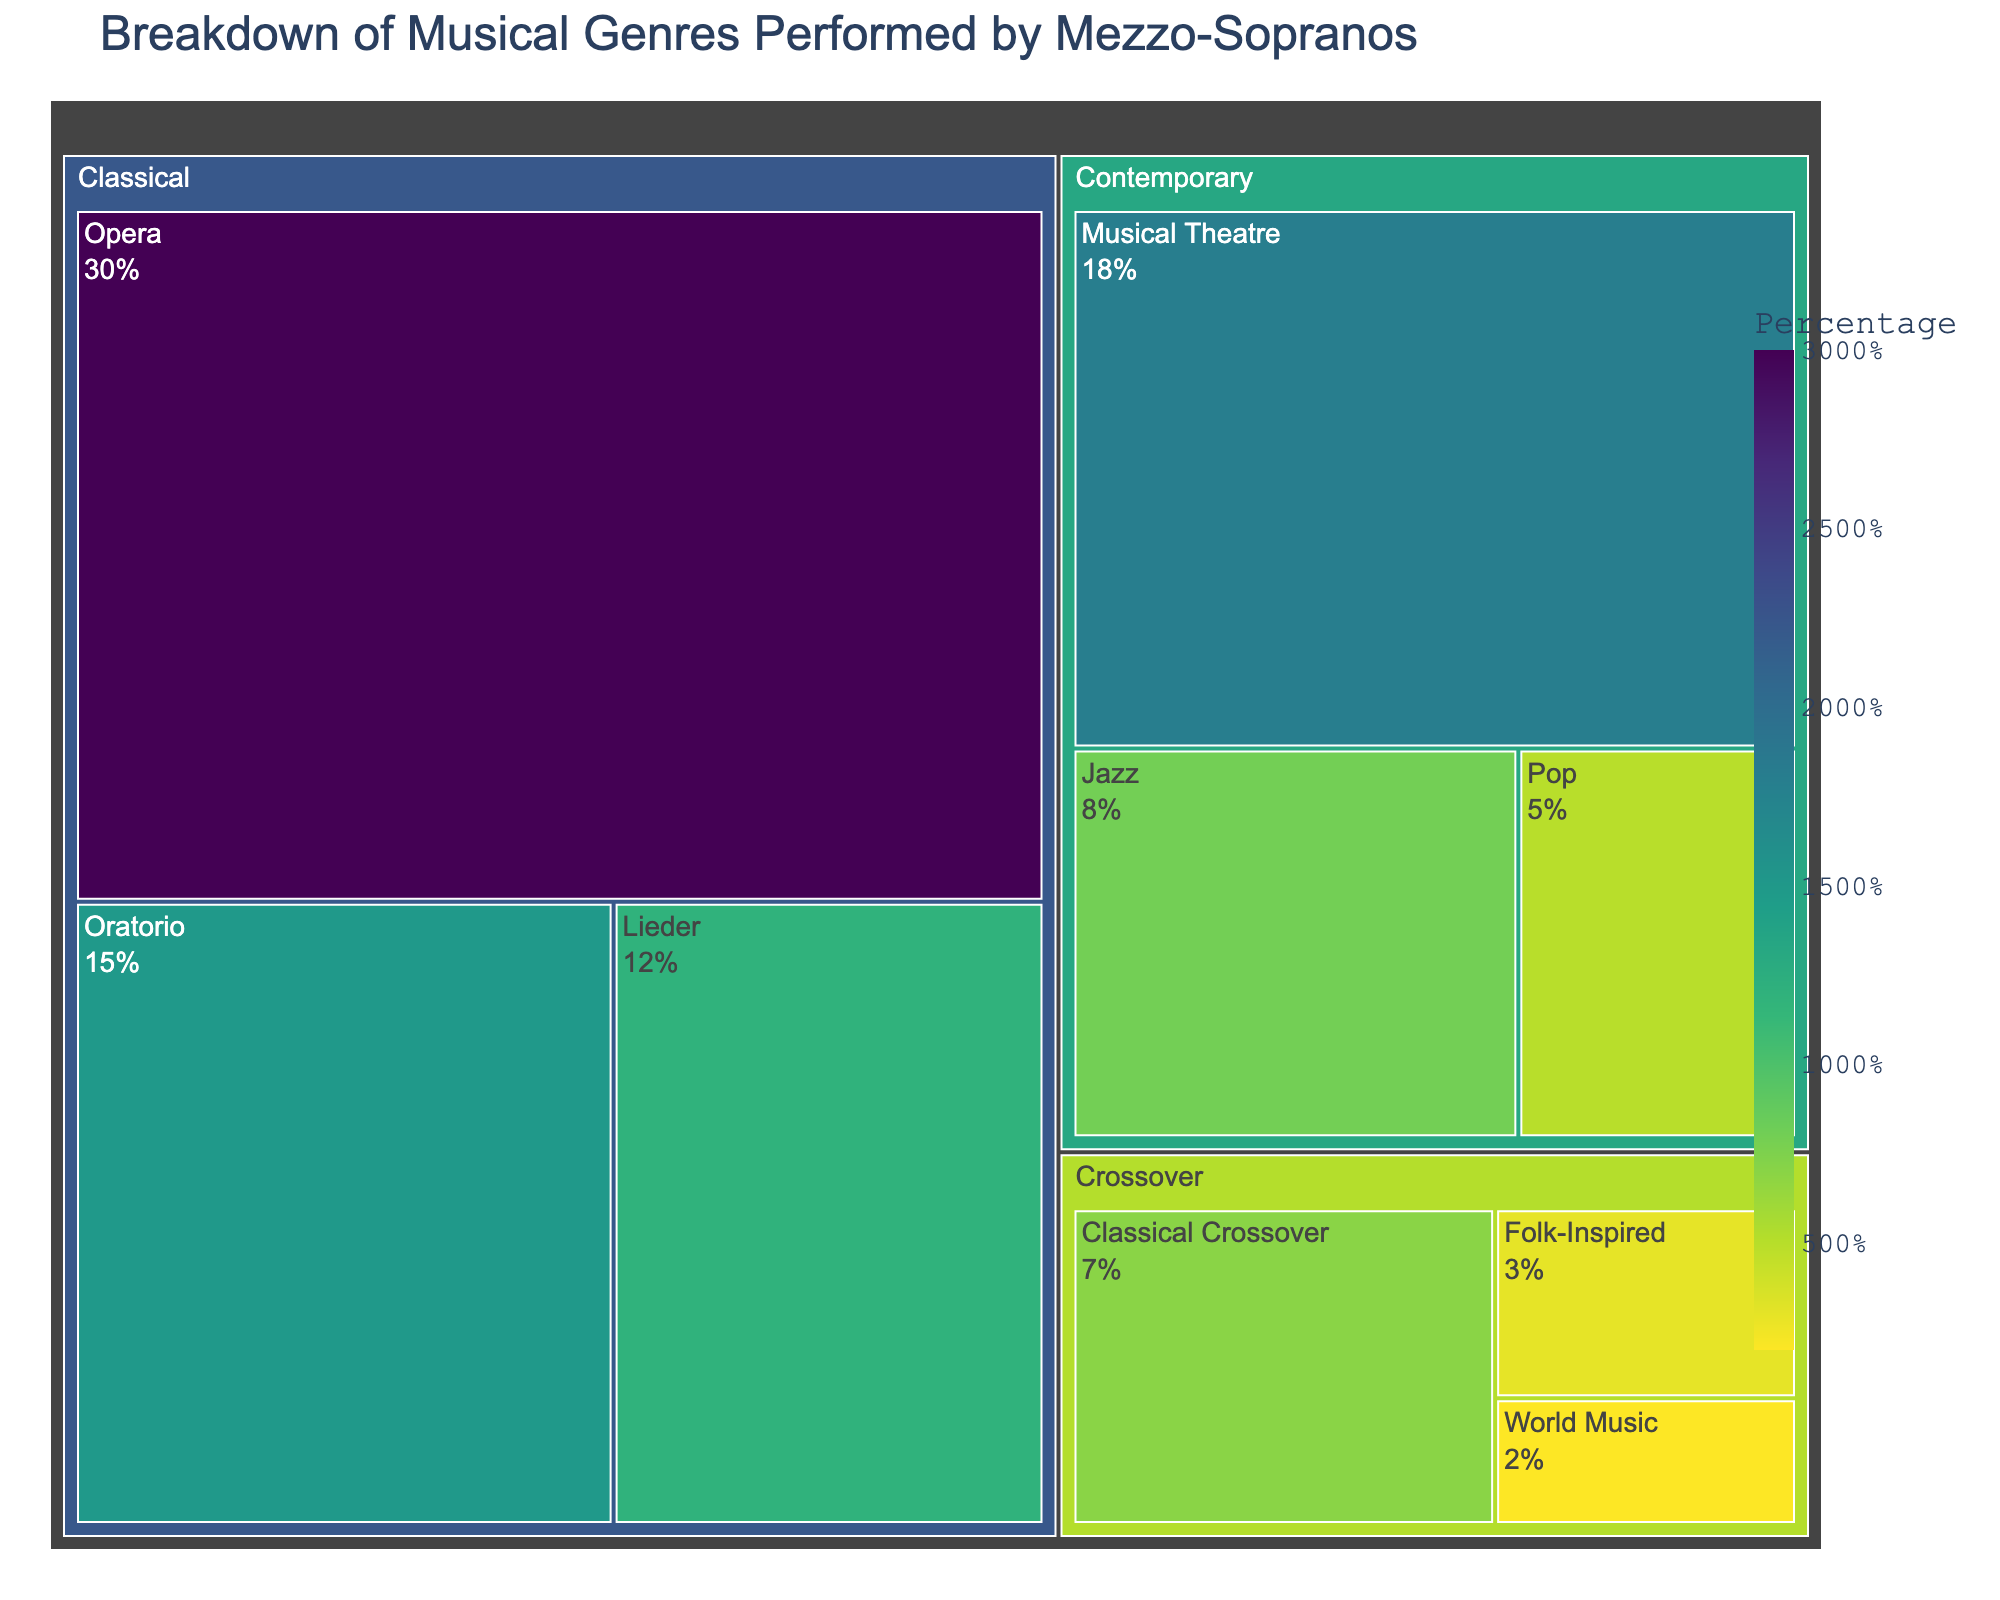What's the title of the figure? The title of the figure is displayed at the top, which gives an overview of the content and purpose of the figure.
Answer: Breakdown of Musical Genres Performed by Mezzo-Sopranos Which genre has the largest segment? By looking at the size of the segments in the treemap, one can identify that the largest segment corresponds to the genre occupying the most space.
Answer: Classical What is the percentage of the Classical genre? The Classical genre is divided into three subgenres, and their percentages are summed up.
Answer: 57% How many subgenres are there in total? By counting all the subgenres listed for each genre in the treemap, one can find the total number.
Answer: 9 Which subgenre has the smallest percentage? The smallest segment in the treemap indicates the subgenre with the lowest percentage.
Answer: World Music What is the combined percentage of the Contemporary genre? Sum up the percentages of the subgenres under Contemporary: Musical Theatre (18%), Jazz (8%), Pop (5%).
Answer: 31% Compare the percentage of Opera and Lieder. Which one is higher? Look for the respective segments for Opera and Lieder under the Classical genre to compare their percentages.
Answer: Opera is higher with 30% compared to Lieder's 12% Which subgenre within the Crossover genre has a greater percentage: Classical Crossover or Folk-Inspired? Compare the segment sizes and percentages listed for both Classical Crossover and Folk-Inspired under the Crossover genre.
Answer: Classical Crossover with 7% What is the total percentage of subgenres with less than 10% each? Identify and sum up each subgenre percentage that is less than 10%: Jazz (8%), Pop (5%), Classical Crossover (7%), Folk-Inspired (3%), World Music (2%).
Answer: 25% What is the median percentage value across all subgenres? First, list all the subgenre percentages in ascending order (2%, 3%, 5%, 7%, 8%, 12%, 15%, 18%, 30%), and find the middle value.
Answer: 8% Compare the total percentage of Classical and Crossover genres. Which one is greater? Sum the subgenre percentages of each genre: Classical (30% + 15% + 12%) and Crossover (7% + 3% + 2%). Compare the sums.
Answer: Classical with 57% 